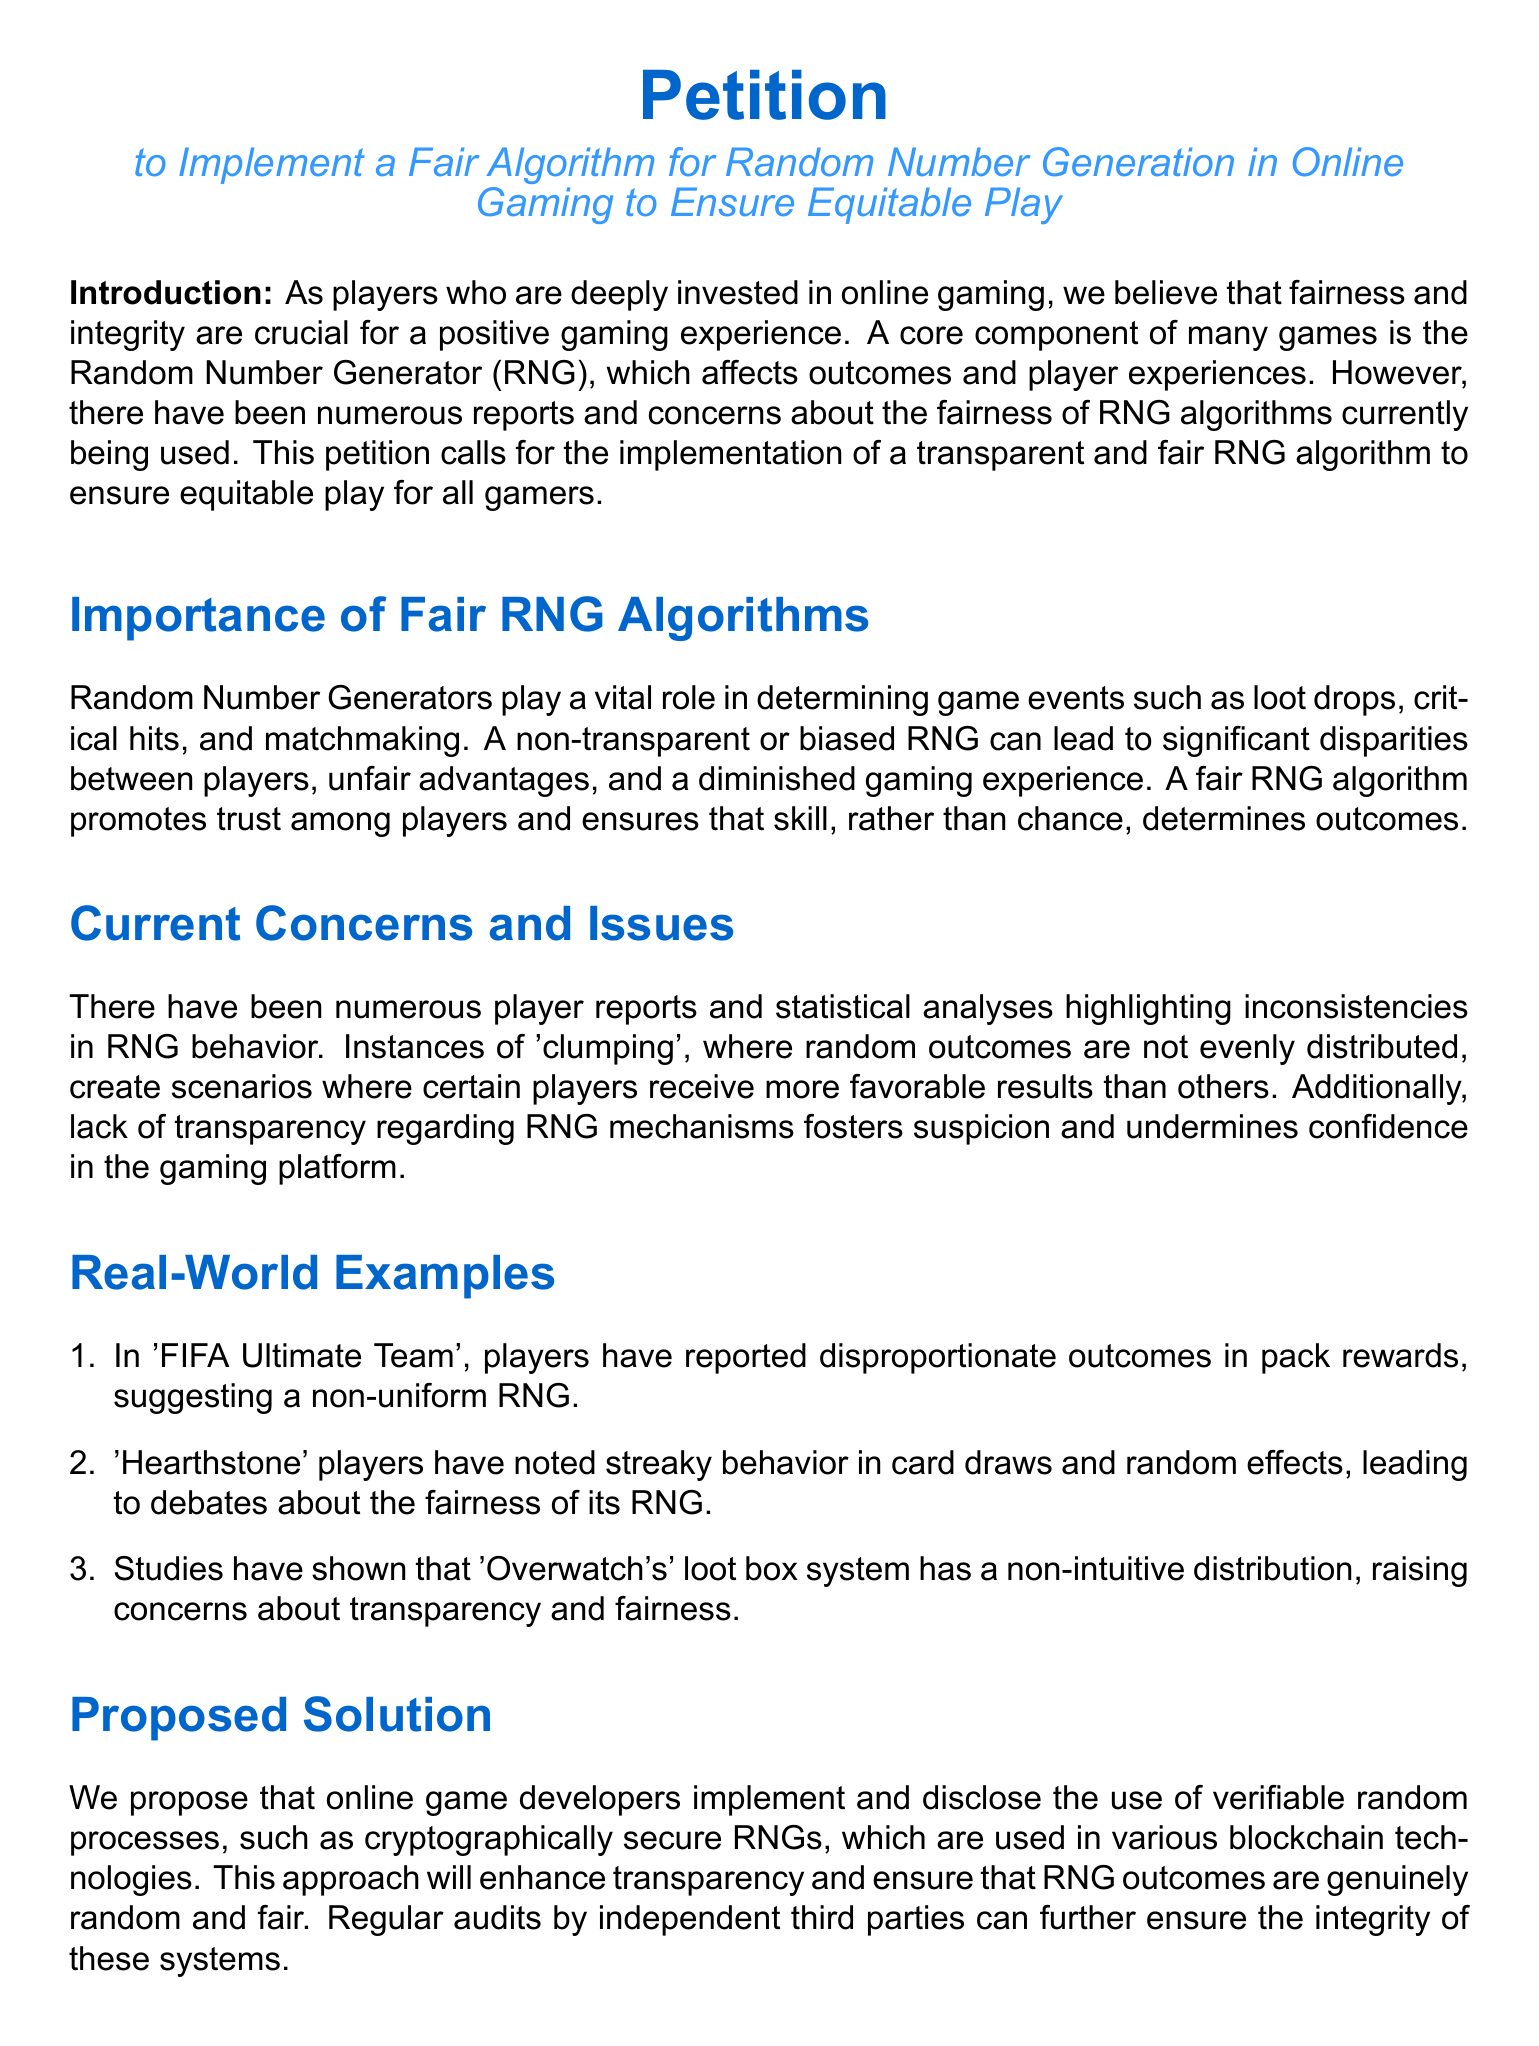What is the title of the petition? The title of the petition, as mentioned at the top of the document, is "Petition to Implement a Fair Algorithm for Random Number Generation in Online Gaming to Ensure Equitable Play."
Answer: Petition to Implement a Fair Algorithm for Random Number Generation in Online Gaming to Ensure Equitable Play Who is urging game developers to take action? The introduction states that "we, the undersigned," are urging game developers, which implies that the players signing the petition request action.
Answer: players What does RNG stand for? The document introduces RNG in the context of the petition and refers to it as "Random Number Generator."
Answer: Random Number Generator What is one proposed solution mentioned in the petition? The document suggests implementing and disclosing the use of "verifiable random processes," specifically mentioning "cryptographically secure RNGs."
Answer: cryptographically secure RNGs What game is mentioned regarding pack rewards? In the real-world examples section, the game "FIFA Ultimate Team" is cited with regards to reported inconsistencies in outcomes and pack rewards.
Answer: FIFA Ultimate Team What color is used for the main text? The document employs Arial font which is colored with the defined main color, RGB (0,102,204).
Answer: maincolor What type of transparency is being called for in RNG mechanisms? The petition emphasizes the need for "transparency" concerning RNG mechanisms to foster player trust.
Answer: transparency Who are the game developers specifically mentioned in the call to action? The petition specifically mentions "Electronic Arts, Blizzard Entertainment, and Riot Games" as game developers that are urged to adopt fair RNG algorithms.
Answer: Electronic Arts, Blizzard Entertainment, and Riot Games 